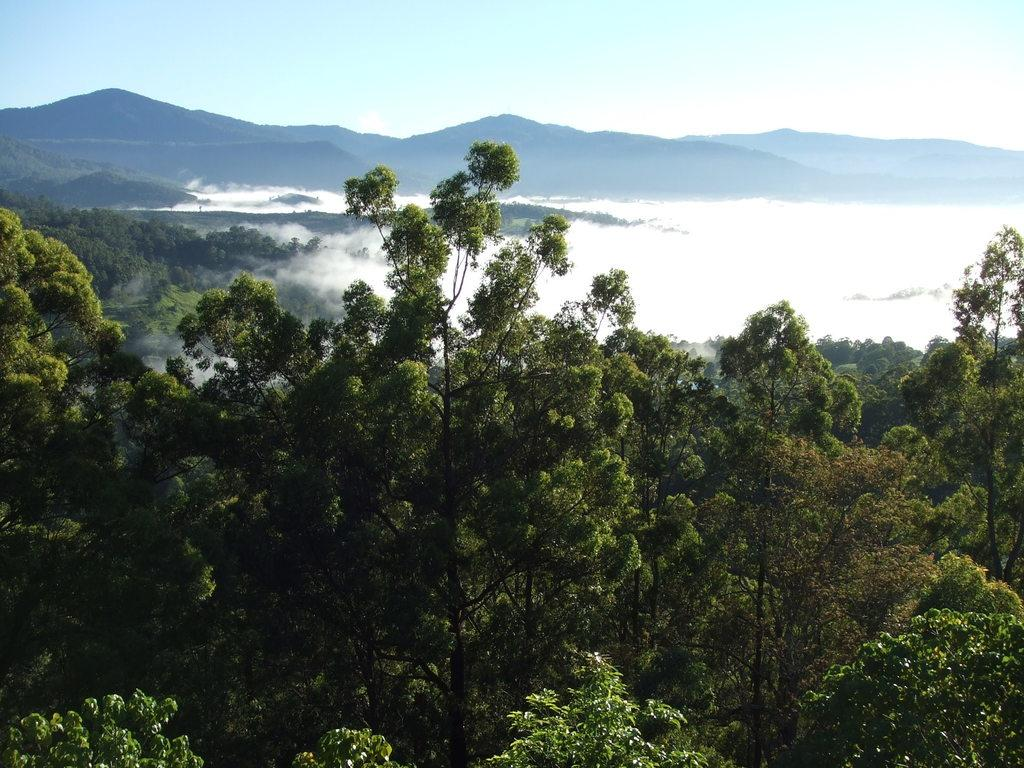What can be seen in the background of the image? The sky is visible in the image. What is the condition of the sky in the image? Clouds are present in the sky. What type of geographical feature can be seen in the image? There are hills in the image. What is the weather like in the image? Fog is present in the image. What type of vegetation is visible in the image? Trees are visible in the image. What type of harmony is being displayed by the thing in the image? There is no specific "thing" mentioned in the image, and the concept of harmony is not applicable to the elements present in the image. 